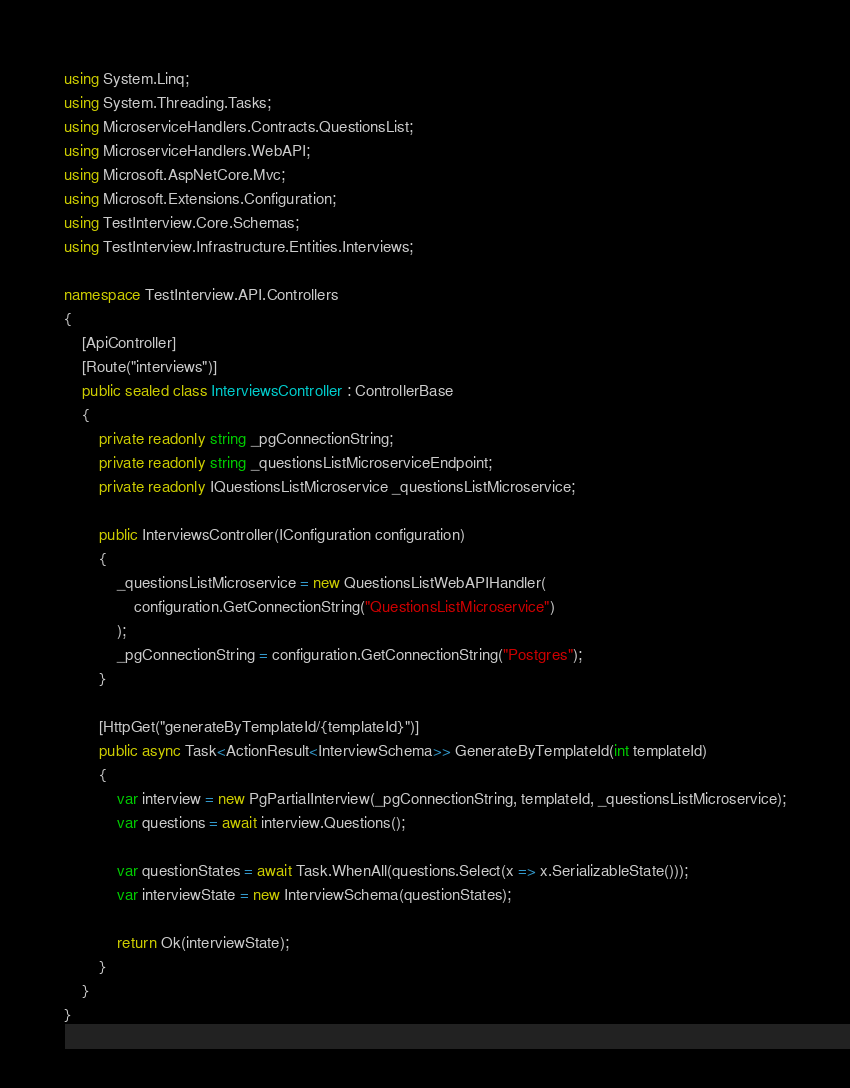<code> <loc_0><loc_0><loc_500><loc_500><_C#_>using System.Linq;
using System.Threading.Tasks;
using MicroserviceHandlers.Contracts.QuestionsList;
using MicroserviceHandlers.WebAPI;
using Microsoft.AspNetCore.Mvc;
using Microsoft.Extensions.Configuration;
using TestInterview.Core.Schemas;
using TestInterview.Infrastructure.Entities.Interviews;

namespace TestInterview.API.Controllers
{
    [ApiController]
    [Route("interviews")]
    public sealed class InterviewsController : ControllerBase
    {
        private readonly string _pgConnectionString;
        private readonly string _questionsListMicroserviceEndpoint;
        private readonly IQuestionsListMicroservice _questionsListMicroservice;

        public InterviewsController(IConfiguration configuration)
        {
            _questionsListMicroservice = new QuestionsListWebAPIHandler(
                configuration.GetConnectionString("QuestionsListMicroservice")
            );
            _pgConnectionString = configuration.GetConnectionString("Postgres");
        }

        [HttpGet("generateByTemplateId/{templateId}")]
        public async Task<ActionResult<InterviewSchema>> GenerateByTemplateId(int templateId)
        {
            var interview = new PgPartialInterview(_pgConnectionString, templateId, _questionsListMicroservice);
            var questions = await interview.Questions();

            var questionStates = await Task.WhenAll(questions.Select(x => x.SerializableState()));
            var interviewState = new InterviewSchema(questionStates);

            return Ok(interviewState);
        }
    }
}</code> 